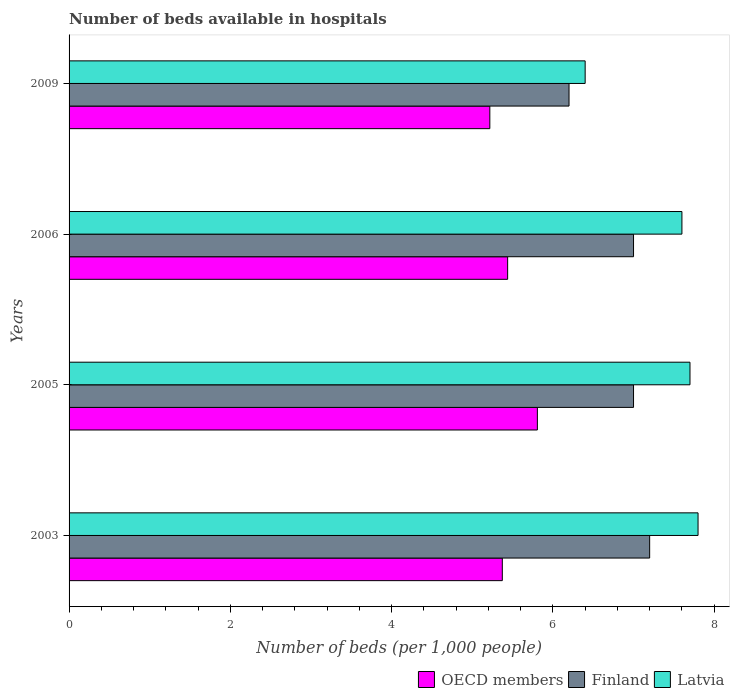Are the number of bars per tick equal to the number of legend labels?
Keep it short and to the point. Yes. How many bars are there on the 4th tick from the bottom?
Your response must be concise. 3. What is the label of the 1st group of bars from the top?
Give a very brief answer. 2009. What is the number of beds in the hospiatls of in Finland in 2003?
Make the answer very short. 7.2. Across all years, what is the maximum number of beds in the hospiatls of in OECD members?
Offer a terse response. 5.81. Across all years, what is the minimum number of beds in the hospiatls of in Latvia?
Your answer should be very brief. 6.4. In which year was the number of beds in the hospiatls of in Latvia maximum?
Your answer should be very brief. 2003. What is the total number of beds in the hospiatls of in OECD members in the graph?
Provide a succinct answer. 21.84. What is the difference between the number of beds in the hospiatls of in Latvia in 2003 and that in 2006?
Ensure brevity in your answer.  0.2. What is the difference between the number of beds in the hospiatls of in Finland in 2009 and the number of beds in the hospiatls of in OECD members in 2003?
Offer a terse response. 0.83. What is the average number of beds in the hospiatls of in Latvia per year?
Give a very brief answer. 7.38. In the year 2005, what is the difference between the number of beds in the hospiatls of in OECD members and number of beds in the hospiatls of in Finland?
Keep it short and to the point. -1.19. What is the ratio of the number of beds in the hospiatls of in OECD members in 2003 to that in 2006?
Make the answer very short. 0.99. Is the number of beds in the hospiatls of in Latvia in 2006 less than that in 2009?
Offer a very short reply. No. Is the difference between the number of beds in the hospiatls of in OECD members in 2003 and 2005 greater than the difference between the number of beds in the hospiatls of in Finland in 2003 and 2005?
Your response must be concise. No. What is the difference between the highest and the second highest number of beds in the hospiatls of in OECD members?
Your response must be concise. 0.37. What is the difference between the highest and the lowest number of beds in the hospiatls of in Latvia?
Provide a short and direct response. 1.4. What does the 2nd bar from the top in 2005 represents?
Your response must be concise. Finland. How many bars are there?
Your answer should be very brief. 12. Are all the bars in the graph horizontal?
Make the answer very short. Yes. How many years are there in the graph?
Offer a terse response. 4. What is the difference between two consecutive major ticks on the X-axis?
Ensure brevity in your answer.  2. Are the values on the major ticks of X-axis written in scientific E-notation?
Keep it short and to the point. No. Does the graph contain any zero values?
Your answer should be very brief. No. Where does the legend appear in the graph?
Provide a succinct answer. Bottom right. How many legend labels are there?
Offer a very short reply. 3. What is the title of the graph?
Your answer should be compact. Number of beds available in hospitals. What is the label or title of the X-axis?
Your response must be concise. Number of beds (per 1,0 people). What is the Number of beds (per 1,000 people) in OECD members in 2003?
Give a very brief answer. 5.37. What is the Number of beds (per 1,000 people) of Finland in 2003?
Keep it short and to the point. 7.2. What is the Number of beds (per 1,000 people) of Latvia in 2003?
Your answer should be very brief. 7.8. What is the Number of beds (per 1,000 people) of OECD members in 2005?
Provide a short and direct response. 5.81. What is the Number of beds (per 1,000 people) in Latvia in 2005?
Offer a terse response. 7.7. What is the Number of beds (per 1,000 people) in OECD members in 2006?
Provide a succinct answer. 5.44. What is the Number of beds (per 1,000 people) of Finland in 2006?
Ensure brevity in your answer.  7. What is the Number of beds (per 1,000 people) of OECD members in 2009?
Offer a terse response. 5.22. What is the Number of beds (per 1,000 people) of Latvia in 2009?
Offer a terse response. 6.4. Across all years, what is the maximum Number of beds (per 1,000 people) in OECD members?
Your answer should be compact. 5.81. Across all years, what is the maximum Number of beds (per 1,000 people) in Finland?
Your response must be concise. 7.2. Across all years, what is the maximum Number of beds (per 1,000 people) of Latvia?
Offer a very short reply. 7.8. Across all years, what is the minimum Number of beds (per 1,000 people) in OECD members?
Keep it short and to the point. 5.22. What is the total Number of beds (per 1,000 people) of OECD members in the graph?
Offer a terse response. 21.84. What is the total Number of beds (per 1,000 people) of Finland in the graph?
Your response must be concise. 27.4. What is the total Number of beds (per 1,000 people) in Latvia in the graph?
Provide a succinct answer. 29.5. What is the difference between the Number of beds (per 1,000 people) in OECD members in 2003 and that in 2005?
Provide a short and direct response. -0.43. What is the difference between the Number of beds (per 1,000 people) in Finland in 2003 and that in 2005?
Your answer should be very brief. 0.2. What is the difference between the Number of beds (per 1,000 people) of Latvia in 2003 and that in 2005?
Provide a short and direct response. 0.1. What is the difference between the Number of beds (per 1,000 people) of OECD members in 2003 and that in 2006?
Ensure brevity in your answer.  -0.07. What is the difference between the Number of beds (per 1,000 people) of Finland in 2003 and that in 2006?
Your response must be concise. 0.2. What is the difference between the Number of beds (per 1,000 people) in OECD members in 2003 and that in 2009?
Give a very brief answer. 0.15. What is the difference between the Number of beds (per 1,000 people) in Latvia in 2003 and that in 2009?
Ensure brevity in your answer.  1.4. What is the difference between the Number of beds (per 1,000 people) of OECD members in 2005 and that in 2006?
Provide a succinct answer. 0.37. What is the difference between the Number of beds (per 1,000 people) in Finland in 2005 and that in 2006?
Make the answer very short. 0. What is the difference between the Number of beds (per 1,000 people) of OECD members in 2005 and that in 2009?
Offer a terse response. 0.59. What is the difference between the Number of beds (per 1,000 people) in Finland in 2005 and that in 2009?
Offer a terse response. 0.8. What is the difference between the Number of beds (per 1,000 people) in Latvia in 2005 and that in 2009?
Make the answer very short. 1.3. What is the difference between the Number of beds (per 1,000 people) of OECD members in 2006 and that in 2009?
Give a very brief answer. 0.22. What is the difference between the Number of beds (per 1,000 people) of Finland in 2006 and that in 2009?
Keep it short and to the point. 0.8. What is the difference between the Number of beds (per 1,000 people) in OECD members in 2003 and the Number of beds (per 1,000 people) in Finland in 2005?
Make the answer very short. -1.63. What is the difference between the Number of beds (per 1,000 people) of OECD members in 2003 and the Number of beds (per 1,000 people) of Latvia in 2005?
Ensure brevity in your answer.  -2.33. What is the difference between the Number of beds (per 1,000 people) of OECD members in 2003 and the Number of beds (per 1,000 people) of Finland in 2006?
Give a very brief answer. -1.63. What is the difference between the Number of beds (per 1,000 people) of OECD members in 2003 and the Number of beds (per 1,000 people) of Latvia in 2006?
Provide a succinct answer. -2.23. What is the difference between the Number of beds (per 1,000 people) of OECD members in 2003 and the Number of beds (per 1,000 people) of Finland in 2009?
Provide a succinct answer. -0.83. What is the difference between the Number of beds (per 1,000 people) in OECD members in 2003 and the Number of beds (per 1,000 people) in Latvia in 2009?
Offer a very short reply. -1.03. What is the difference between the Number of beds (per 1,000 people) of OECD members in 2005 and the Number of beds (per 1,000 people) of Finland in 2006?
Offer a very short reply. -1.19. What is the difference between the Number of beds (per 1,000 people) of OECD members in 2005 and the Number of beds (per 1,000 people) of Latvia in 2006?
Your response must be concise. -1.79. What is the difference between the Number of beds (per 1,000 people) in Finland in 2005 and the Number of beds (per 1,000 people) in Latvia in 2006?
Provide a succinct answer. -0.6. What is the difference between the Number of beds (per 1,000 people) of OECD members in 2005 and the Number of beds (per 1,000 people) of Finland in 2009?
Make the answer very short. -0.39. What is the difference between the Number of beds (per 1,000 people) of OECD members in 2005 and the Number of beds (per 1,000 people) of Latvia in 2009?
Ensure brevity in your answer.  -0.59. What is the difference between the Number of beds (per 1,000 people) of Finland in 2005 and the Number of beds (per 1,000 people) of Latvia in 2009?
Your response must be concise. 0.6. What is the difference between the Number of beds (per 1,000 people) of OECD members in 2006 and the Number of beds (per 1,000 people) of Finland in 2009?
Your answer should be very brief. -0.76. What is the difference between the Number of beds (per 1,000 people) in OECD members in 2006 and the Number of beds (per 1,000 people) in Latvia in 2009?
Provide a succinct answer. -0.96. What is the difference between the Number of beds (per 1,000 people) of Finland in 2006 and the Number of beds (per 1,000 people) of Latvia in 2009?
Provide a succinct answer. 0.6. What is the average Number of beds (per 1,000 people) in OECD members per year?
Your answer should be very brief. 5.46. What is the average Number of beds (per 1,000 people) in Finland per year?
Your response must be concise. 6.85. What is the average Number of beds (per 1,000 people) in Latvia per year?
Provide a succinct answer. 7.38. In the year 2003, what is the difference between the Number of beds (per 1,000 people) of OECD members and Number of beds (per 1,000 people) of Finland?
Provide a short and direct response. -1.83. In the year 2003, what is the difference between the Number of beds (per 1,000 people) of OECD members and Number of beds (per 1,000 people) of Latvia?
Offer a very short reply. -2.43. In the year 2005, what is the difference between the Number of beds (per 1,000 people) of OECD members and Number of beds (per 1,000 people) of Finland?
Your answer should be compact. -1.19. In the year 2005, what is the difference between the Number of beds (per 1,000 people) in OECD members and Number of beds (per 1,000 people) in Latvia?
Keep it short and to the point. -1.89. In the year 2006, what is the difference between the Number of beds (per 1,000 people) in OECD members and Number of beds (per 1,000 people) in Finland?
Provide a short and direct response. -1.56. In the year 2006, what is the difference between the Number of beds (per 1,000 people) of OECD members and Number of beds (per 1,000 people) of Latvia?
Your answer should be very brief. -2.16. In the year 2009, what is the difference between the Number of beds (per 1,000 people) of OECD members and Number of beds (per 1,000 people) of Finland?
Offer a terse response. -0.98. In the year 2009, what is the difference between the Number of beds (per 1,000 people) of OECD members and Number of beds (per 1,000 people) of Latvia?
Ensure brevity in your answer.  -1.18. In the year 2009, what is the difference between the Number of beds (per 1,000 people) of Finland and Number of beds (per 1,000 people) of Latvia?
Offer a terse response. -0.2. What is the ratio of the Number of beds (per 1,000 people) of OECD members in 2003 to that in 2005?
Give a very brief answer. 0.93. What is the ratio of the Number of beds (per 1,000 people) of Finland in 2003 to that in 2005?
Your answer should be compact. 1.03. What is the ratio of the Number of beds (per 1,000 people) in OECD members in 2003 to that in 2006?
Give a very brief answer. 0.99. What is the ratio of the Number of beds (per 1,000 people) in Finland in 2003 to that in 2006?
Your answer should be very brief. 1.03. What is the ratio of the Number of beds (per 1,000 people) of Latvia in 2003 to that in 2006?
Provide a succinct answer. 1.03. What is the ratio of the Number of beds (per 1,000 people) of OECD members in 2003 to that in 2009?
Make the answer very short. 1.03. What is the ratio of the Number of beds (per 1,000 people) of Finland in 2003 to that in 2009?
Make the answer very short. 1.16. What is the ratio of the Number of beds (per 1,000 people) of Latvia in 2003 to that in 2009?
Your answer should be very brief. 1.22. What is the ratio of the Number of beds (per 1,000 people) of OECD members in 2005 to that in 2006?
Your response must be concise. 1.07. What is the ratio of the Number of beds (per 1,000 people) of Finland in 2005 to that in 2006?
Your answer should be very brief. 1. What is the ratio of the Number of beds (per 1,000 people) of Latvia in 2005 to that in 2006?
Provide a succinct answer. 1.01. What is the ratio of the Number of beds (per 1,000 people) in OECD members in 2005 to that in 2009?
Give a very brief answer. 1.11. What is the ratio of the Number of beds (per 1,000 people) in Finland in 2005 to that in 2009?
Offer a terse response. 1.13. What is the ratio of the Number of beds (per 1,000 people) in Latvia in 2005 to that in 2009?
Offer a terse response. 1.2. What is the ratio of the Number of beds (per 1,000 people) of OECD members in 2006 to that in 2009?
Make the answer very short. 1.04. What is the ratio of the Number of beds (per 1,000 people) of Finland in 2006 to that in 2009?
Keep it short and to the point. 1.13. What is the ratio of the Number of beds (per 1,000 people) of Latvia in 2006 to that in 2009?
Your answer should be very brief. 1.19. What is the difference between the highest and the second highest Number of beds (per 1,000 people) of OECD members?
Your response must be concise. 0.37. What is the difference between the highest and the second highest Number of beds (per 1,000 people) in Finland?
Give a very brief answer. 0.2. What is the difference between the highest and the lowest Number of beds (per 1,000 people) in OECD members?
Ensure brevity in your answer.  0.59. 